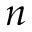<formula> <loc_0><loc_0><loc_500><loc_500>n</formula> 